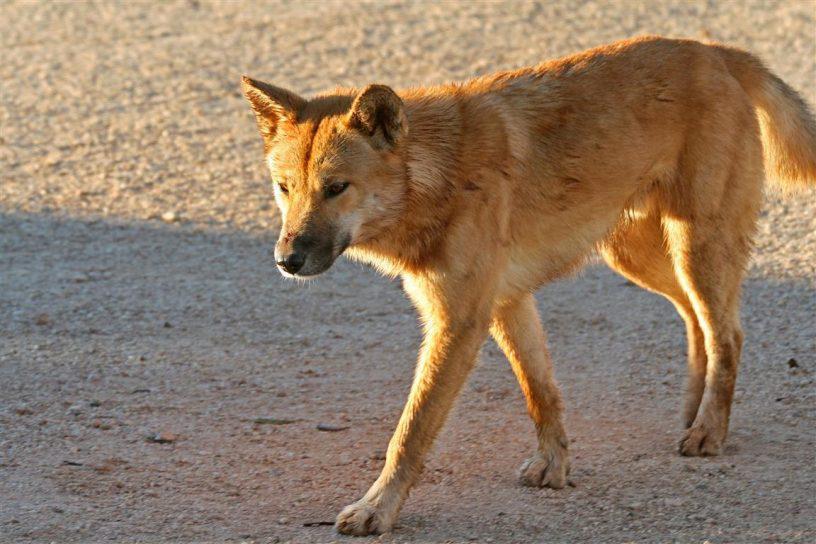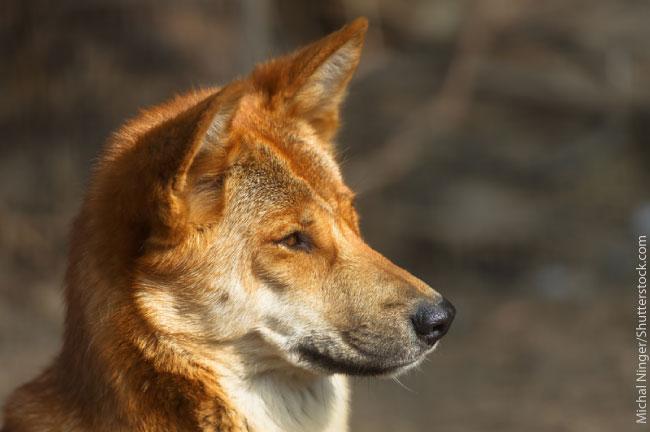The first image is the image on the left, the second image is the image on the right. Examine the images to the left and right. Is the description "There are exactly four animals in the pair of images with at least three of them standing." accurate? Answer yes or no. No. The first image is the image on the left, the second image is the image on the right. For the images displayed, is the sentence "The combined images contain a total of four dingos, and at least three of the dogs are standing." factually correct? Answer yes or no. No. 